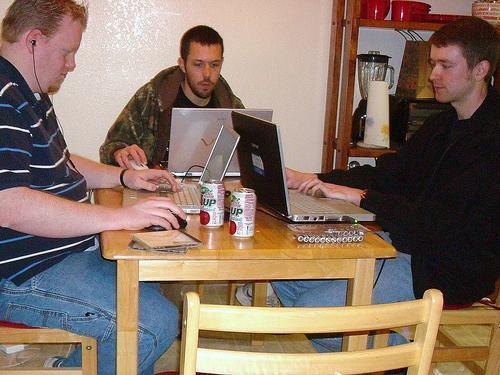How many people are there?
Give a very brief answer. 3. 